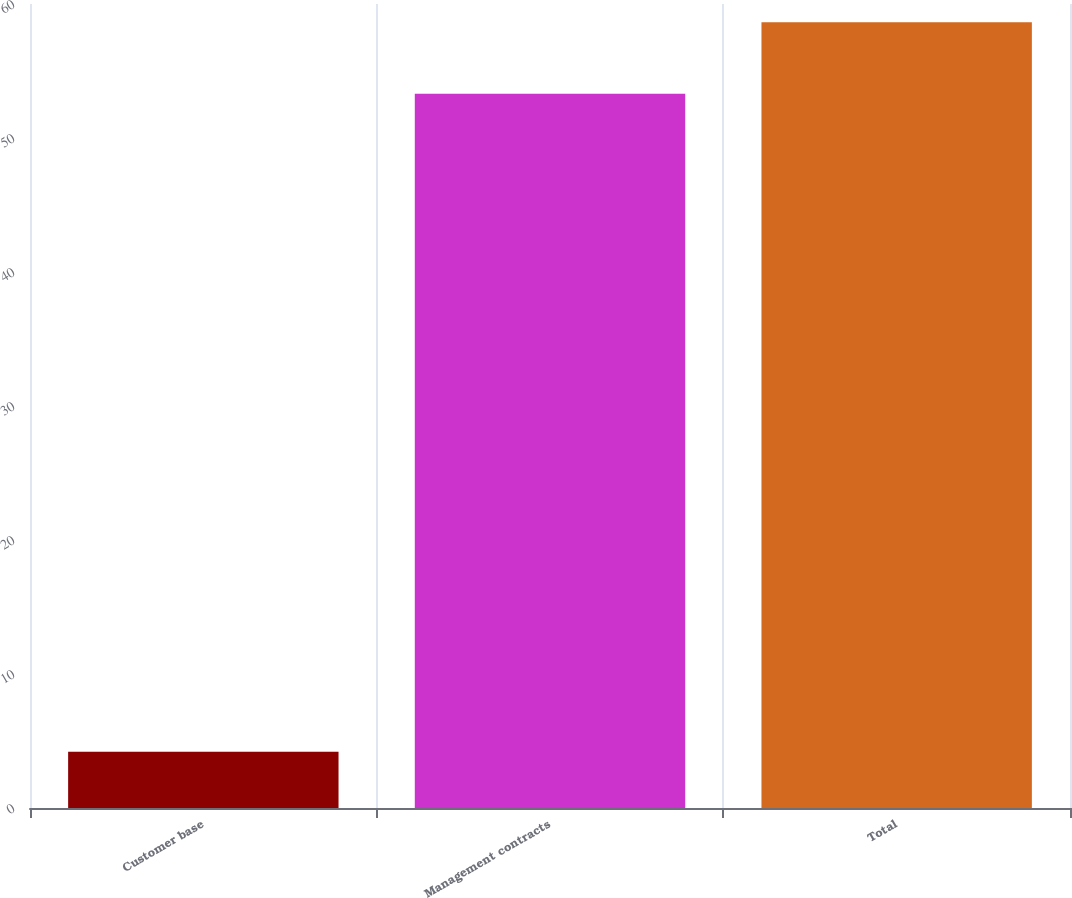Convert chart. <chart><loc_0><loc_0><loc_500><loc_500><bar_chart><fcel>Customer base<fcel>Management contracts<fcel>Total<nl><fcel>4.2<fcel>53.3<fcel>58.63<nl></chart> 